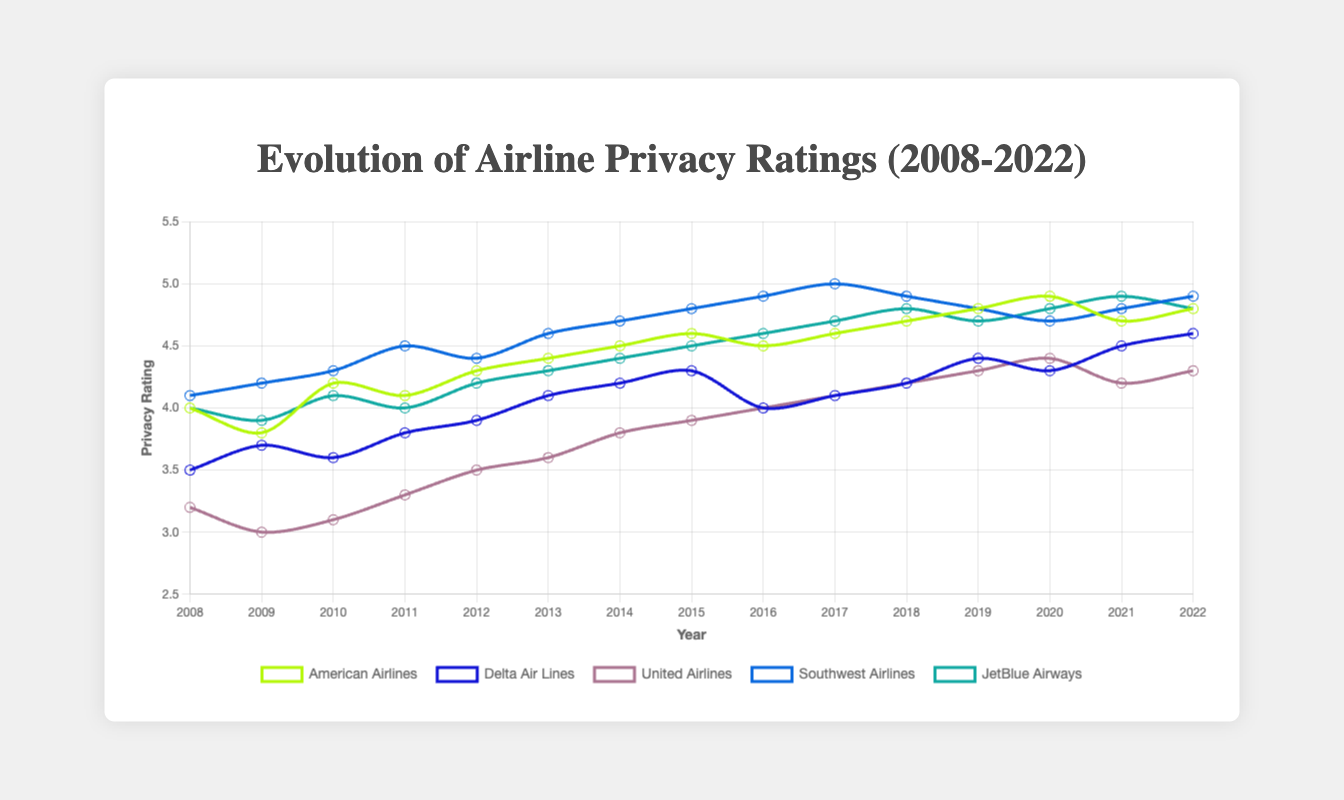Which airline had the highest privacy rating in 2022? By looking at the end of the plot for the year 2022, the highest point belongs to Southwest Airlines with a privacy rating of 4.9.
Answer: Southwest Airlines How did the privacy rating for Delta Air Lines in 2020 compare to its rating in 2008? Observing the plot for Delta Air Lines, its privacy rating in 2008 was 3.5 and in 2020 it was 4.3. It increased by 0.8 points.
Answer: Increased by 0.8 Which airline saw the most significant improvement in privacy rating between 2008 and 2022? Comparing the privacy ratings from 2008 to 2022 for all airlines, United Airlines improved from 3.2 to 4.3, which is an increase of 1.1 points, the highest among all.
Answer: United Airlines What is the average privacy rating of American Airlines from 2008 to 2022? Summing up all privacy ratings for American Airlines from 2008 to 2022 and dividing by the number of years (15): (4.0 + 3.8 + 4.2 + 4.1 + 4.3 + 4.4 + 4.5 + 4.6 + 4.5 + 4.6 + 4.7 + 4.8 + 4.9 + 4.7 + 4.8) / 15 = 4.49.
Answer: 4.49 Which airline had the lowest privacy rating in 2009? Looking at the plot for the year 2009, United Airlines had the lowest privacy rating of 3.0.
Answer: United Airlines Did JetBlue Airways ever have a privacy rating higher than 4.8 in the given period? Observing the entire plot for JetBlue Airways, its highest privacy rating reached 4.9 in 2021.
Answer: Yes Compare the privacy ratings of Southwest Airlines and American Airlines in 2015. Which one was higher, and by how much? In 2015, the privacy rating for Southwest Airlines was 4.8, and for American Airlines, it was 4.6. Southwest Airlines' rating was higher by 0.2 points.
Answer: Southwest Airlines by 0.2 points 